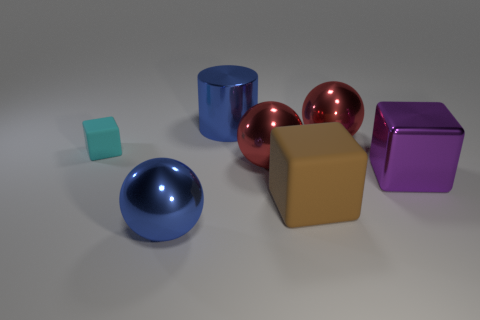Subtract all brown rubber blocks. How many blocks are left? 2 Subtract 1 balls. How many balls are left? 2 Subtract all red blocks. Subtract all green cylinders. How many blocks are left? 3 Add 1 small cubes. How many objects exist? 8 Subtract all cylinders. How many objects are left? 6 Add 4 big brown rubber things. How many big brown rubber things are left? 5 Add 5 big purple cubes. How many big purple cubes exist? 6 Subtract 0 brown balls. How many objects are left? 7 Subtract all large shiny cubes. Subtract all big metallic cylinders. How many objects are left? 5 